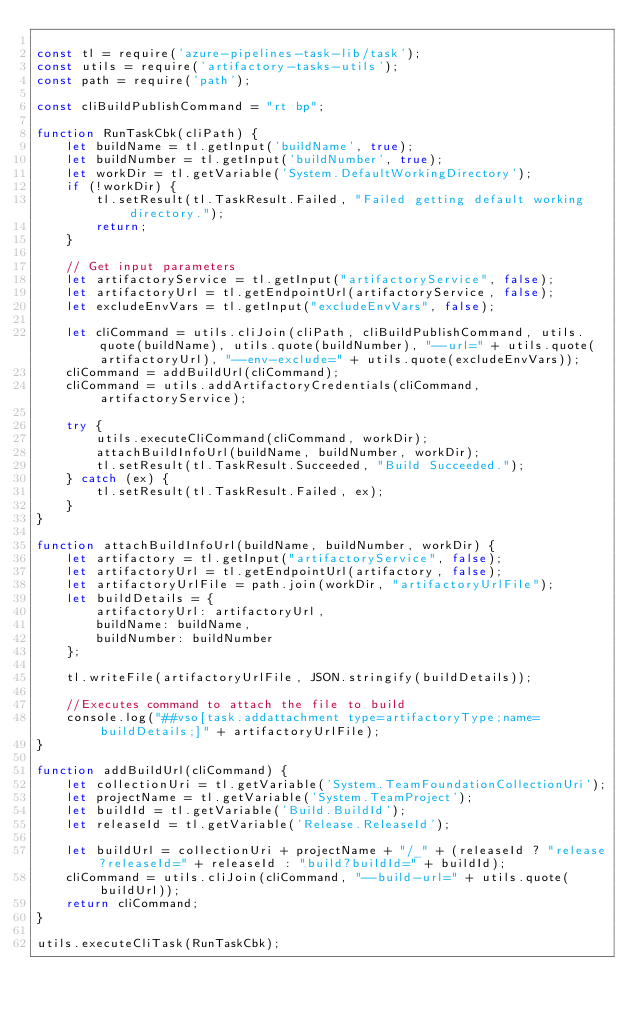Convert code to text. <code><loc_0><loc_0><loc_500><loc_500><_JavaScript_>
const tl = require('azure-pipelines-task-lib/task');
const utils = require('artifactory-tasks-utils');
const path = require('path');

const cliBuildPublishCommand = "rt bp";

function RunTaskCbk(cliPath) {
    let buildName = tl.getInput('buildName', true);
    let buildNumber = tl.getInput('buildNumber', true);
    let workDir = tl.getVariable('System.DefaultWorkingDirectory');
    if (!workDir) {
        tl.setResult(tl.TaskResult.Failed, "Failed getting default working directory.");
        return;
    }

    // Get input parameters
    let artifactoryService = tl.getInput("artifactoryService", false);
    let artifactoryUrl = tl.getEndpointUrl(artifactoryService, false);
    let excludeEnvVars = tl.getInput("excludeEnvVars", false);

    let cliCommand = utils.cliJoin(cliPath, cliBuildPublishCommand, utils.quote(buildName), utils.quote(buildNumber), "--url=" + utils.quote(artifactoryUrl), "--env-exclude=" + utils.quote(excludeEnvVars));
    cliCommand = addBuildUrl(cliCommand);
    cliCommand = utils.addArtifactoryCredentials(cliCommand, artifactoryService);

    try {
        utils.executeCliCommand(cliCommand, workDir);
        attachBuildInfoUrl(buildName, buildNumber, workDir);
        tl.setResult(tl.TaskResult.Succeeded, "Build Succeeded.");
    } catch (ex) {
        tl.setResult(tl.TaskResult.Failed, ex);
    }
}

function attachBuildInfoUrl(buildName, buildNumber, workDir) {
    let artifactory = tl.getInput("artifactoryService", false);
    let artifactoryUrl = tl.getEndpointUrl(artifactory, false);
    let artifactoryUrlFile = path.join(workDir, "artifactoryUrlFile");
    let buildDetails = {
        artifactoryUrl: artifactoryUrl,
        buildName: buildName,
        buildNumber: buildNumber
    };

    tl.writeFile(artifactoryUrlFile, JSON.stringify(buildDetails));

    //Executes command to attach the file to build
    console.log("##vso[task.addattachment type=artifactoryType;name=buildDetails;]" + artifactoryUrlFile);
}

function addBuildUrl(cliCommand) {
    let collectionUri = tl.getVariable('System.TeamFoundationCollectionUri');
    let projectName = tl.getVariable('System.TeamProject');
    let buildId = tl.getVariable('Build.BuildId');
    let releaseId = tl.getVariable('Release.ReleaseId');

    let buildUrl = collectionUri + projectName + "/_" + (releaseId ? "release?releaseId=" + releaseId : "build?buildId=" + buildId);
    cliCommand = utils.cliJoin(cliCommand, "--build-url=" + utils.quote(buildUrl));
    return cliCommand;
}

utils.executeCliTask(RunTaskCbk);
</code> 